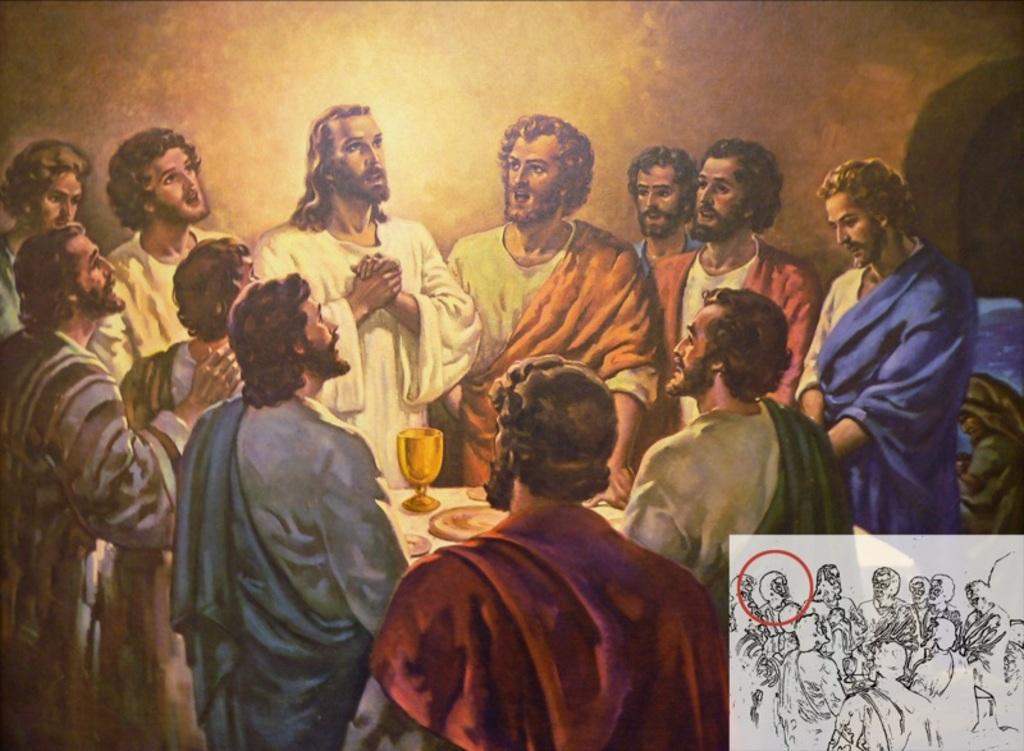How would you summarize this image in a sentence or two? In this image there is a painting. There are group of men standing. In between them there is a table. On the table there are plates and a glass. Behind them there is a wall. In the bottom right there is a black and white picture. 